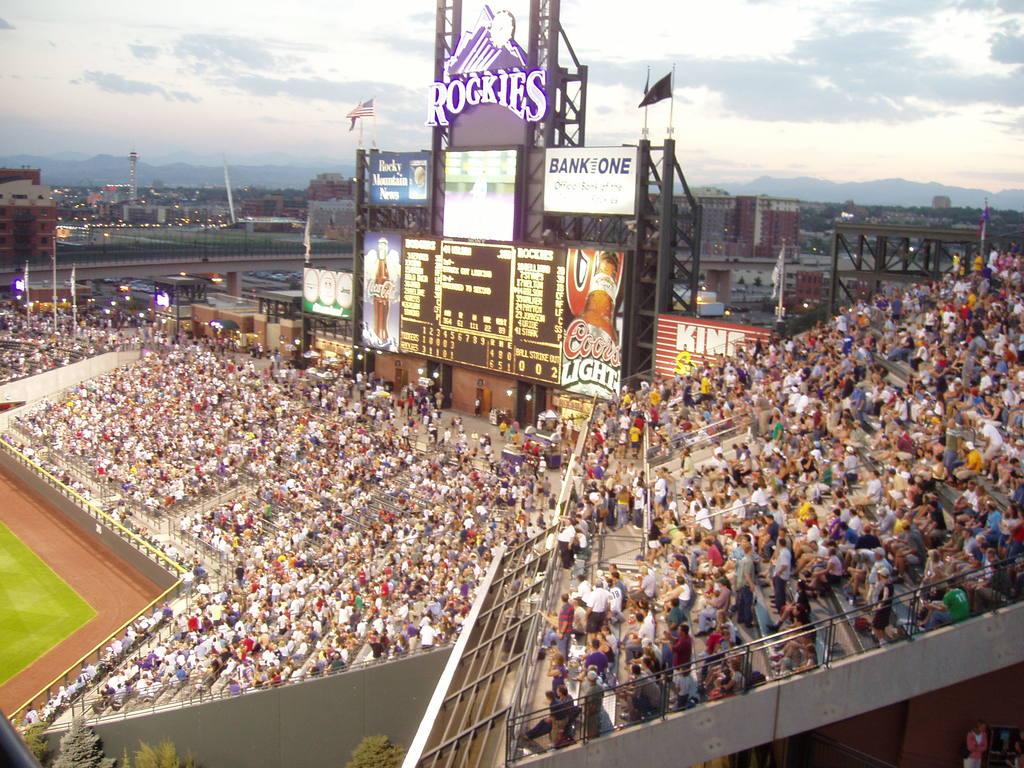Which bank is a sponsor?
Ensure brevity in your answer.  Bank one. 